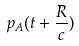<formula> <loc_0><loc_0><loc_500><loc_500>p _ { A } ( t + \frac { R } { c } )</formula> 